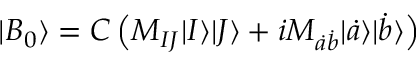Convert formula to latex. <formula><loc_0><loc_0><loc_500><loc_500>| B _ { 0 } \rangle = C \left ( M _ { I J } | I \rangle | J \rangle + i M _ { \dot { a } \dot { b } } | \dot { a } \rangle | \dot { b } \rangle \right )</formula> 